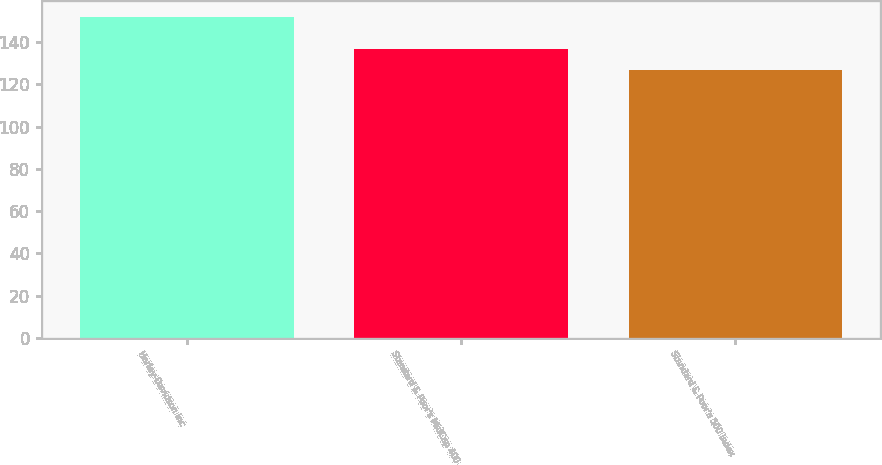Convert chart. <chart><loc_0><loc_0><loc_500><loc_500><bar_chart><fcel>Harley-Davidson Inc<fcel>Standard & Poor's MidCap 400<fcel>Standard & Poor's 500 Index<nl><fcel>152<fcel>137<fcel>127<nl></chart> 